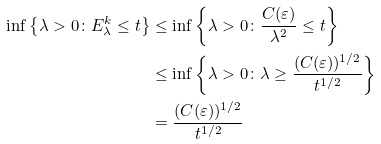Convert formula to latex. <formula><loc_0><loc_0><loc_500><loc_500>\inf \left \{ \lambda > 0 \colon E ^ { k } _ { \lambda } \leq t \right \} & \leq \inf \left \{ \lambda > 0 \colon \frac { C ( \varepsilon ) } { \lambda ^ { 2 } } \leq t \right \} \\ & \leq \inf \left \{ \lambda > 0 \colon \lambda \geq \frac { ( C ( \varepsilon ) ) ^ { 1 / 2 } } { t ^ { 1 / 2 } } \right \} \\ & = \frac { ( C ( \varepsilon ) ) ^ { 1 / 2 } } { t ^ { 1 / 2 } }</formula> 